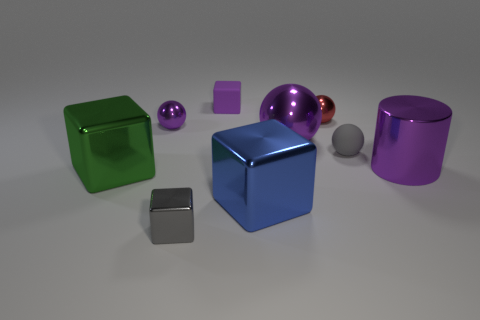How many purple objects are to the left of the big metallic object right of the gray sphere?
Keep it short and to the point. 3. The red object that is made of the same material as the big blue block is what shape?
Offer a very short reply. Sphere. Is the big sphere the same color as the small metallic cube?
Your answer should be compact. No. Is the material of the purple sphere right of the gray cube the same as the tiny gray thing behind the big blue object?
Provide a short and direct response. No. How many objects are purple rubber things or gray shiny blocks that are to the left of the tiny matte ball?
Make the answer very short. 2. There is a matte thing that is the same color as the metal cylinder; what is its shape?
Your answer should be compact. Cube. What material is the small purple cube?
Provide a succinct answer. Rubber. Is the blue thing made of the same material as the cylinder?
Provide a succinct answer. Yes. How many metal things are blocks or large cylinders?
Ensure brevity in your answer.  4. There is a big purple object that is behind the matte sphere; what shape is it?
Your response must be concise. Sphere. 